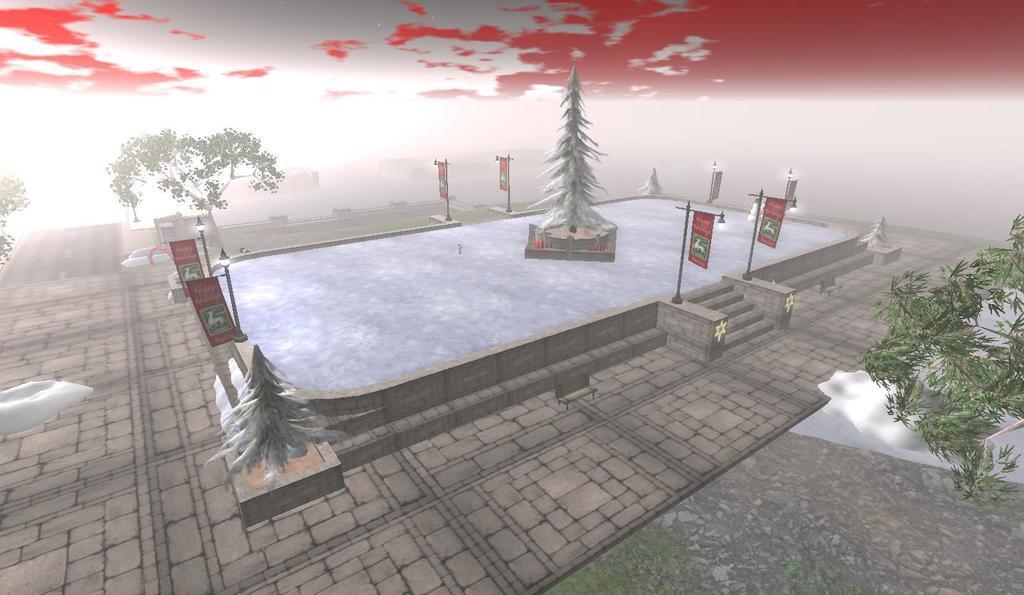In one or two sentences, can you explain what this image depicts? This is an animated picture. In the center of the image we can see a pool which contains water and also we can see the bushes, poles, lights, boards, tree, stairs. In the background of the image we can see the floor, snow and trees. At the top of the image we can see the clouds are present in the sky. 